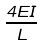Convert formula to latex. <formula><loc_0><loc_0><loc_500><loc_500>\frac { 4 E I } { L }</formula> 